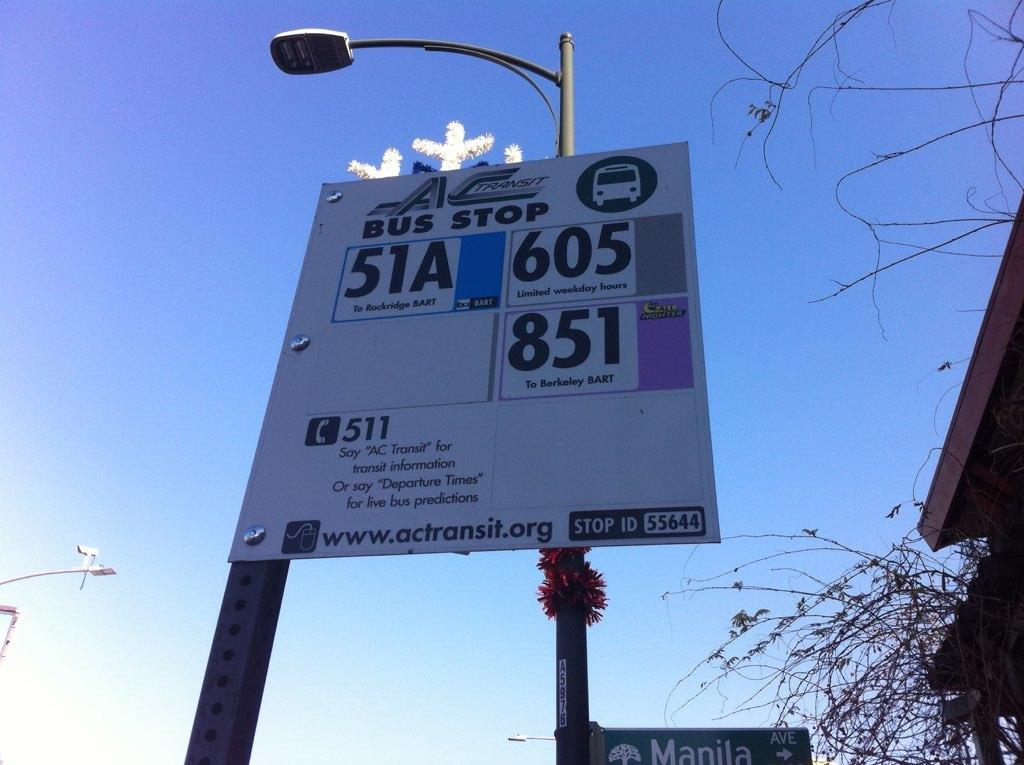<image>
Create a compact narrative representing the image presented. Bus stop 51A takes you to Rockridge BART. 